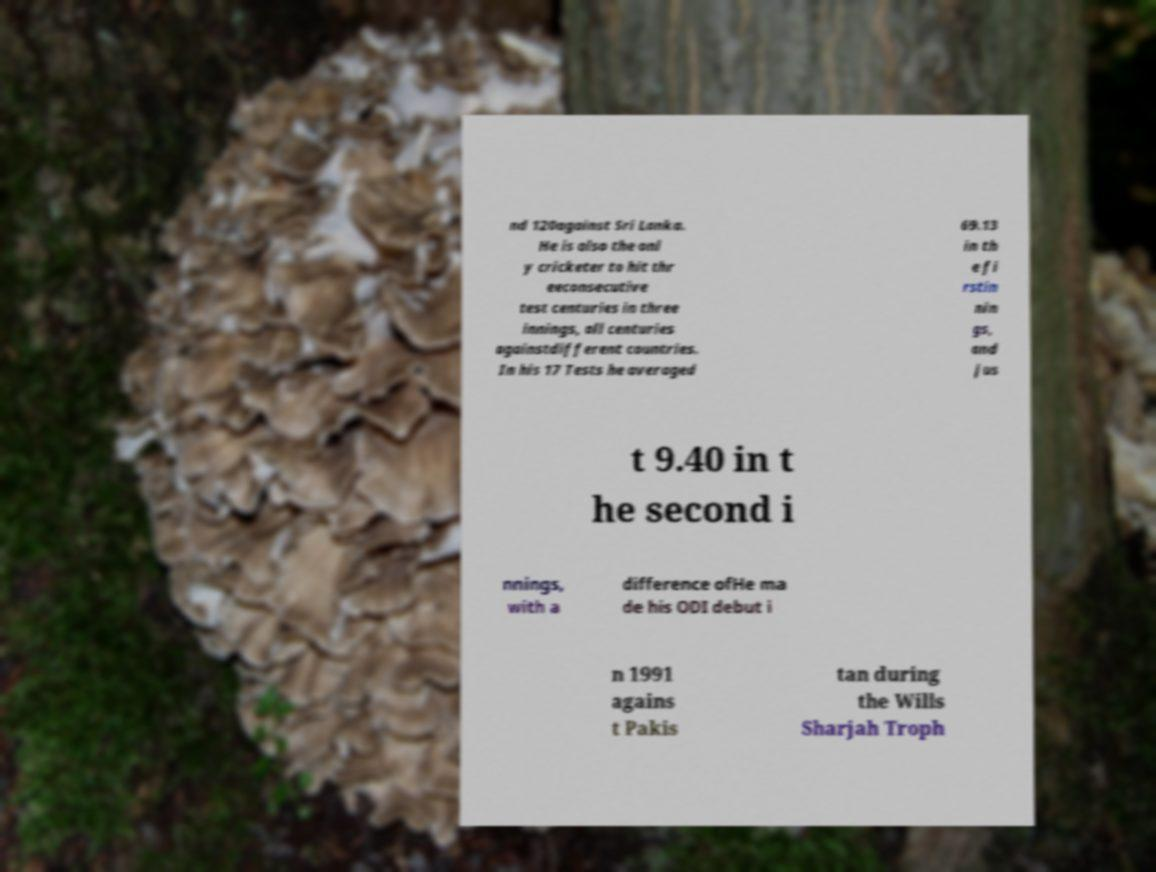There's text embedded in this image that I need extracted. Can you transcribe it verbatim? Certainly! The text in the image reads: 'nd 120against Sri Lanka. He is also the onl y cricketer to hit thr eeconsecutive test centuries in three innings, all centuries againstdifferent countries. In his 17 Tests he averaged 69.13 in th e fi rstin nin gs, and jus t 9.40 in t he second innings, with a difference ofHe ma de his ODI debut i n 1991 agains t Pakis tan during the Wills Sharjah Troph.' 